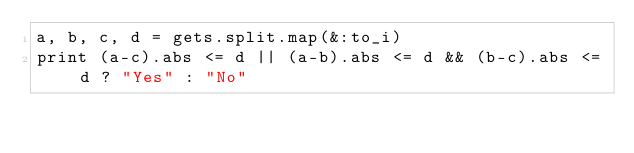Convert code to text. <code><loc_0><loc_0><loc_500><loc_500><_Ruby_>a, b, c, d = gets.split.map(&:to_i)
print (a-c).abs <= d || (a-b).abs <= d && (b-c).abs <= d ? "Yes" : "No"</code> 